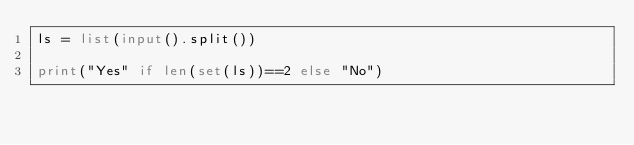Convert code to text. <code><loc_0><loc_0><loc_500><loc_500><_Python_>ls = list(input().split())

print("Yes" if len(set(ls))==2 else "No")</code> 